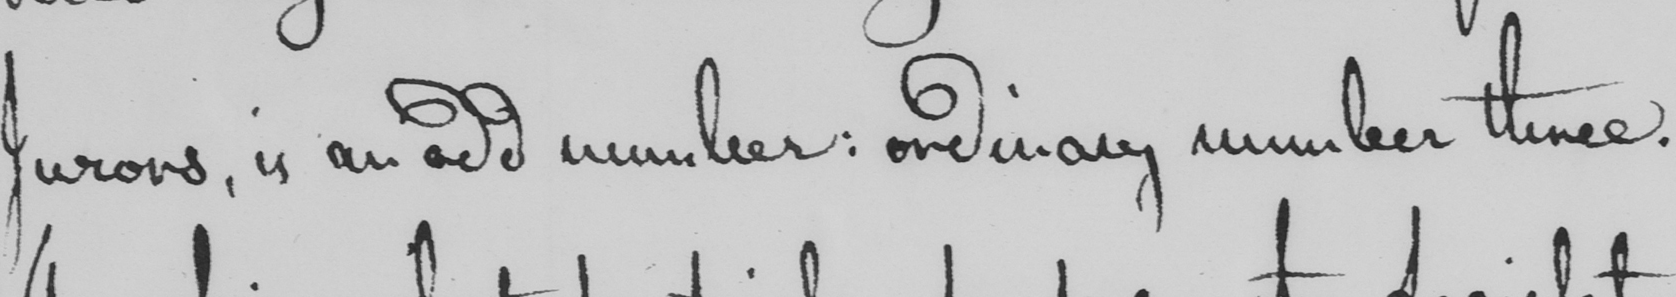What text is written in this handwritten line? Jurors , is an odd number :  ordinary number three . 